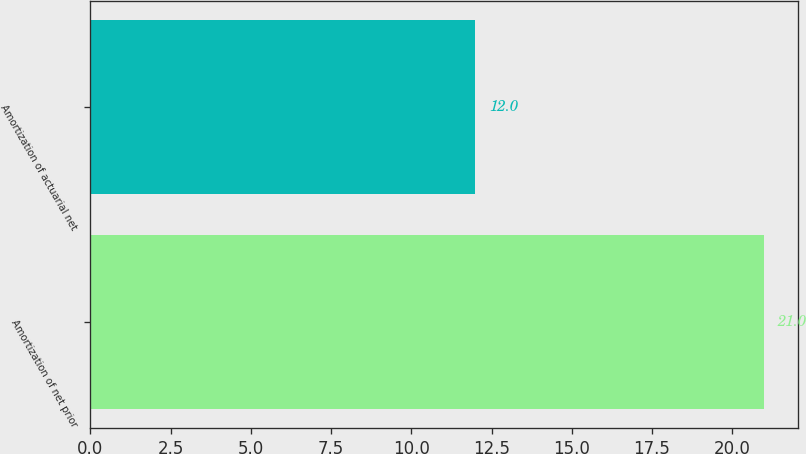Convert chart to OTSL. <chart><loc_0><loc_0><loc_500><loc_500><bar_chart><fcel>Amortization of net prior<fcel>Amortization of actuarial net<nl><fcel>21<fcel>12<nl></chart> 